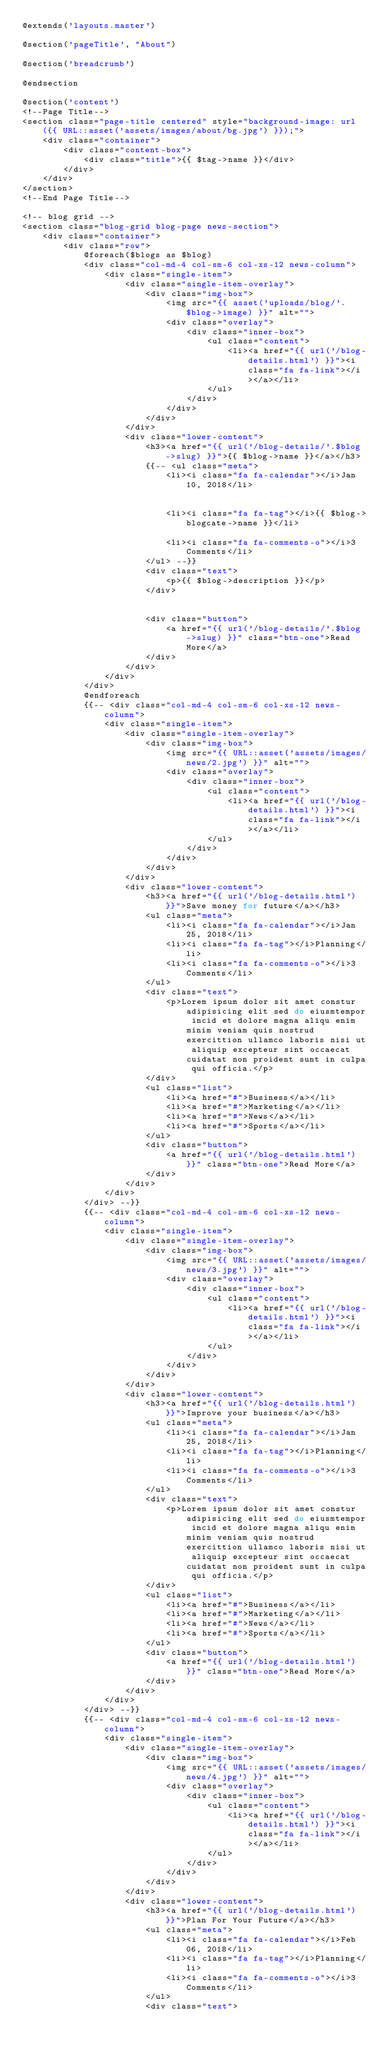Convert code to text. <code><loc_0><loc_0><loc_500><loc_500><_PHP_>@extends('layouts.master')

@section('pageTitle', "About")

@section('breadcrumb')
    
@endsection

@section('content')
<!--Page Title-->
<section class="page-title centered" style="background-image: url({{ URL::asset('assets/images/about/bg.jpg') }});">
    <div class="container">
        <div class="content-box">
            <div class="title">{{ $tag->name }}</div>
        </div>
    </div>
</section>
<!--End Page Title-->

<!-- blog grid -->
<section class="blog-grid blog-page news-section">
    <div class="container">
        <div class="row">
            @foreach($blogs as $blog)
            <div class="col-md-4 col-sm-6 col-xs-12 news-column">
                <div class="single-item">
                    <div class="single-item-overlay">
                        <div class="img-box">
                            <img src="{{ asset('uploads/blog/'.$blog->image) }}" alt="">
                            <div class="overlay">
                                <div class="inner-box">
                                    <ul class="content">
                                        <li><a href="{{ url('/blog-details.html') }}"><i class="fa fa-link"></i></a></li>
                                    </ul>
                                </div> 
                            </div>
                        </div>
                    </div>
                    <div class="lower-content">
                        <h3><a href="{{ url('/blog-details/'.$blog->slug) }}">{{ $blog->name }}</a></h3>
                        {{-- <ul class="meta">
                            <li><i class="fa fa-calendar"></i>Jan 10, 2018</li>
                            
                            
                            <li><i class="fa fa-tag"></i>{{ $blog->blogcate->name }}</li>
                            
                            <li><i class="fa fa-comments-o"></i>3 Comments</li>
                        </ul> --}}
                        <div class="text">
                            <p>{{ $blog->description }}</p>
                        </div>
                        
                        
                        <div class="button">
                            <a href="{{ url('/blog-details/'.$blog->slug) }}" class="btn-one">Read More</a>
                        </div>
                    </div>
                </div>
            </div>
            @endforeach
            {{-- <div class="col-md-4 col-sm-6 col-xs-12 news-column">
                <div class="single-item">
                    <div class="single-item-overlay">
                        <div class="img-box">
                            <img src="{{ URL::asset('assets/images/news/2.jpg') }}" alt="">
                            <div class="overlay">
                                <div class="inner-box">
                                    <ul class="content">
                                        <li><a href="{{ url('/blog-details.html') }}"><i class="fa fa-link"></i></a></li>
                                    </ul>
                                </div> 
                            </div>
                        </div>
                    </div>
                    <div class="lower-content">
                        <h3><a href="{{ url('/blog-details.html') }}">Save money for future</a></h3>
                        <ul class="meta">
                            <li><i class="fa fa-calendar"></i>Jan 25, 2018</li>
                            <li><i class="fa fa-tag"></i>Planning</li>
                            <li><i class="fa fa-comments-o"></i>3 Comments</li>
                        </ul>
                        <div class="text">
                            <p>Lorem ipsum dolor sit amet constur adipisicing elit sed do eiusmtempor incid et dolore magna aliqu enim minim veniam quis nostrud exercittion ullamco laboris nisi ut aliquip excepteur sint occaecat cuidatat non proident sunt in culpa qui officia.</p>
                        </div>
                        <ul class="list">
                            <li><a href="#">Business</a></li>
                            <li><a href="#">Marketing</a></li>
                            <li><a href="#">News</a></li>
                            <li><a href="#">Sports</a></li>
                        </ul>
                        <div class="button">
                            <a href="{{ url('/blog-details.html') }}" class="btn-one">Read More</a>
                        </div>
                    </div>
                </div>
            </div> --}}
            {{-- <div class="col-md-4 col-sm-6 col-xs-12 news-column">
                <div class="single-item">
                    <div class="single-item-overlay">
                        <div class="img-box">
                            <img src="{{ URL::asset('assets/images/news/3.jpg') }}" alt="">
                            <div class="overlay">
                                <div class="inner-box">
                                    <ul class="content">
                                        <li><a href="{{ url('/blog-details.html') }}"><i class="fa fa-link"></i></a></li>
                                    </ul>
                                </div> 
                            </div>
                        </div>
                    </div>
                    <div class="lower-content">
                        <h3><a href="{{ url('/blog-details.html') }}">Improve your business</a></h3>
                        <ul class="meta">
                            <li><i class="fa fa-calendar"></i>Jan 25, 2018</li>
                            <li><i class="fa fa-tag"></i>Planning</li>
                            <li><i class="fa fa-comments-o"></i>3 Comments</li>
                        </ul>
                        <div class="text">
                            <p>Lorem ipsum dolor sit amet constur adipisicing elit sed do eiusmtempor incid et dolore magna aliqu enim minim veniam quis nostrud exercittion ullamco laboris nisi ut aliquip excepteur sint occaecat cuidatat non proident sunt in culpa qui officia.</p>
                        </div>
                        <ul class="list">
                            <li><a href="#">Business</a></li>
                            <li><a href="#">Marketing</a></li>
                            <li><a href="#">News</a></li>
                            <li><a href="#">Sports</a></li>
                        </ul>
                        <div class="button">
                            <a href="{{ url('/blog-details.html') }}" class="btn-one">Read More</a>
                        </div>
                    </div>
                </div>
            </div> --}}
            {{-- <div class="col-md-4 col-sm-6 col-xs-12 news-column">
                <div class="single-item">
                    <div class="single-item-overlay">
                        <div class="img-box">
                            <img src="{{ URL::asset('assets/images/news/4.jpg') }}" alt="">
                            <div class="overlay">
                                <div class="inner-box">
                                    <ul class="content">
                                        <li><a href="{{ url('/blog-details.html') }}"><i class="fa fa-link"></i></a></li>
                                    </ul>
                                </div> 
                            </div>
                        </div>
                    </div>
                    <div class="lower-content">
                        <h3><a href="{{ url('/blog-details.html') }}">Plan For Your Future</a></h3>
                        <ul class="meta">
                            <li><i class="fa fa-calendar"></i>Feb 06, 2018</li>
                            <li><i class="fa fa-tag"></i>Planning</li>
                            <li><i class="fa fa-comments-o"></i>3 Comments</li>
                        </ul>
                        <div class="text"></code> 